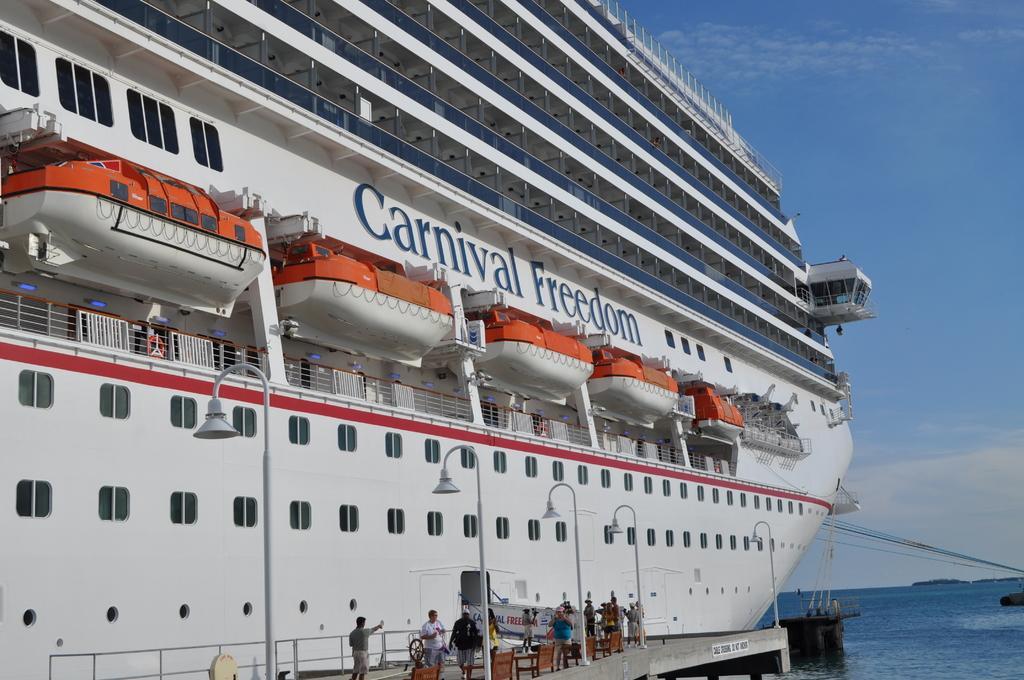In one or two sentences, can you explain what this image depicts? This picture is clicked outside. On the right we can see a water body and some objects in the water body. On the left there is a ship and we can see the text on the ship. In the foreground we can see the lampposts, chairs, metal rods, text on the banner, group of people seems to be walking on the bridge. In the background we can see the sky and the cables. 